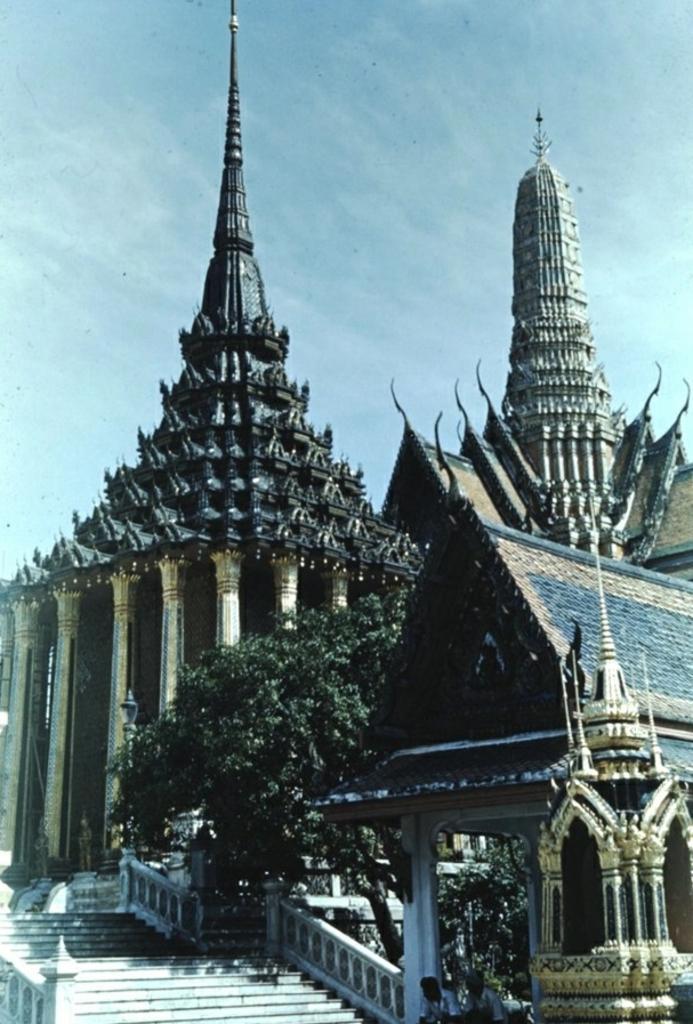Please provide a concise description of this image. To the bottom left of the image there are steps with railing. And in the background there are trees and also there are buildings with walls, pillars and roofs. To the top of the image there is a sky. 